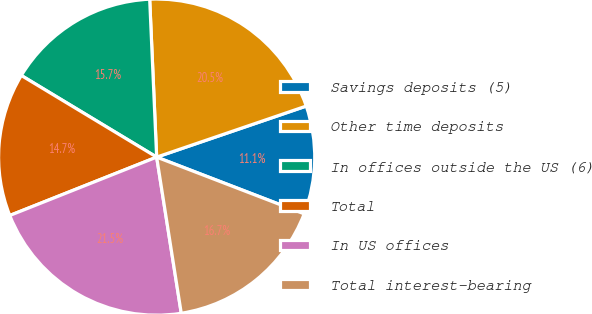<chart> <loc_0><loc_0><loc_500><loc_500><pie_chart><fcel>Savings deposits (5)<fcel>Other time deposits<fcel>In offices outside the US (6)<fcel>Total<fcel>In US offices<fcel>Total interest-bearing<nl><fcel>11.08%<fcel>20.47%<fcel>15.66%<fcel>14.66%<fcel>21.47%<fcel>16.67%<nl></chart> 